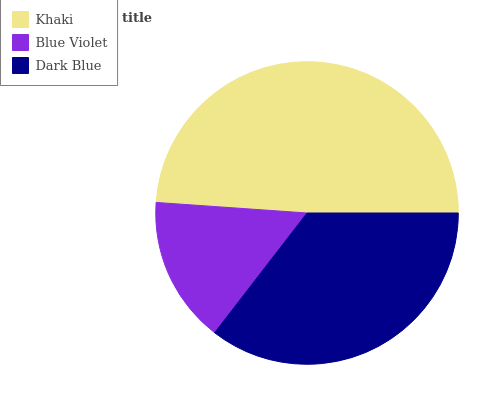Is Blue Violet the minimum?
Answer yes or no. Yes. Is Khaki the maximum?
Answer yes or no. Yes. Is Dark Blue the minimum?
Answer yes or no. No. Is Dark Blue the maximum?
Answer yes or no. No. Is Dark Blue greater than Blue Violet?
Answer yes or no. Yes. Is Blue Violet less than Dark Blue?
Answer yes or no. Yes. Is Blue Violet greater than Dark Blue?
Answer yes or no. No. Is Dark Blue less than Blue Violet?
Answer yes or no. No. Is Dark Blue the high median?
Answer yes or no. Yes. Is Dark Blue the low median?
Answer yes or no. Yes. Is Khaki the high median?
Answer yes or no. No. Is Khaki the low median?
Answer yes or no. No. 